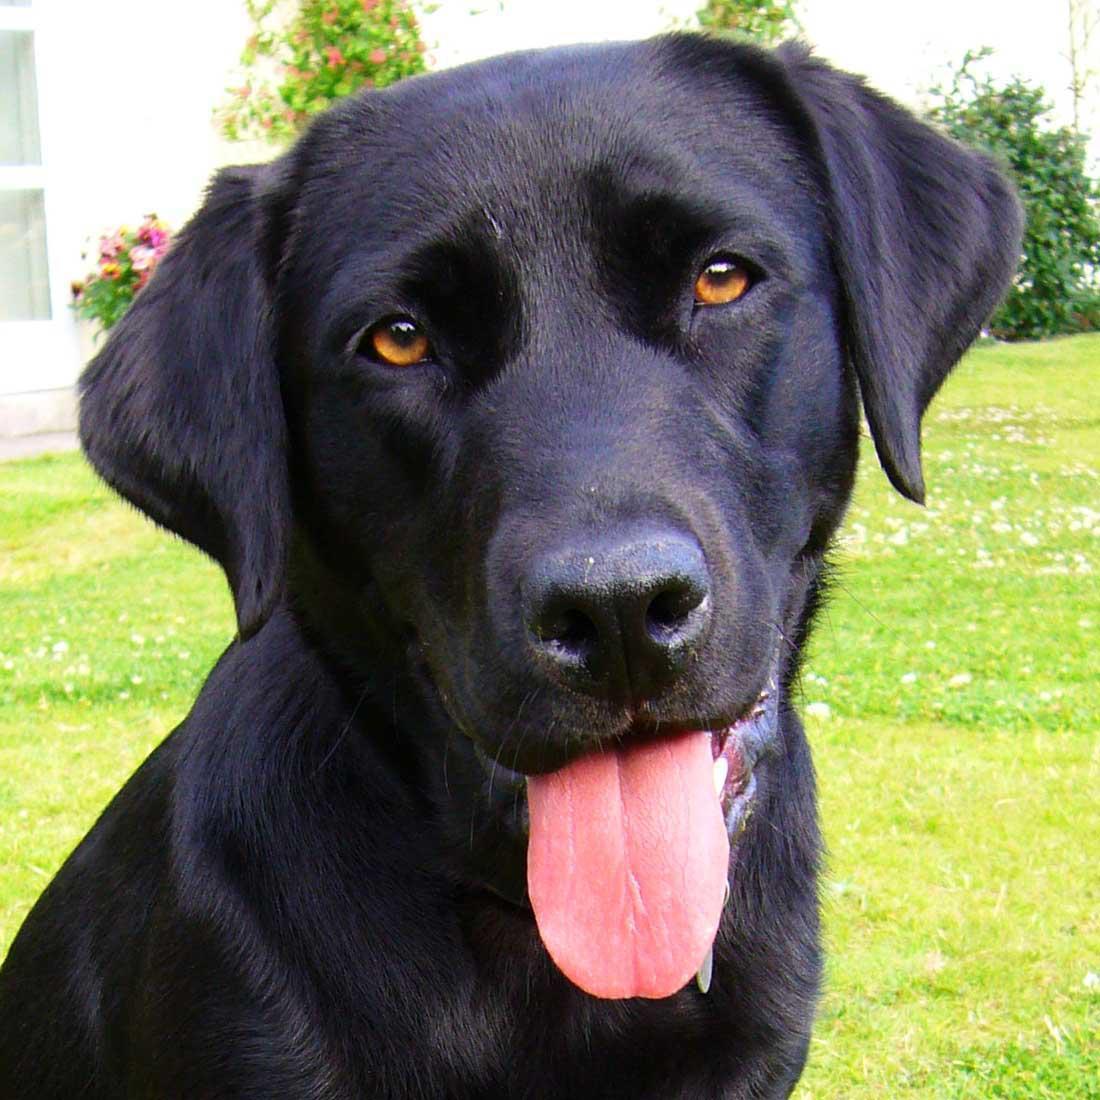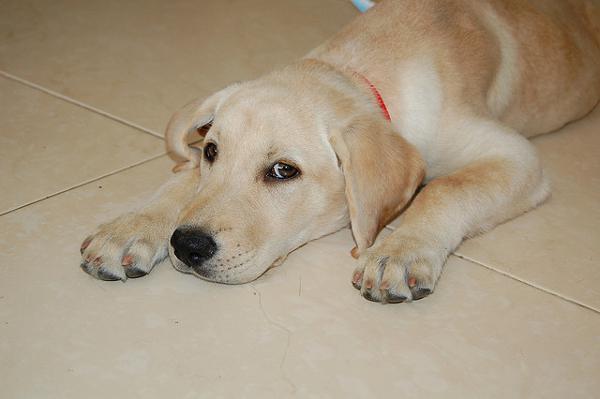The first image is the image on the left, the second image is the image on the right. For the images shown, is this caption "There is a total of six dogs." true? Answer yes or no. No. 